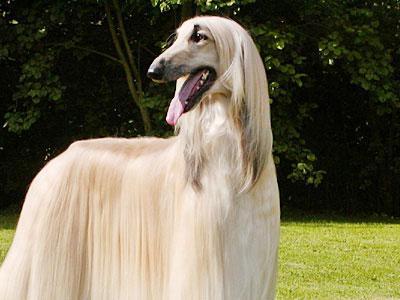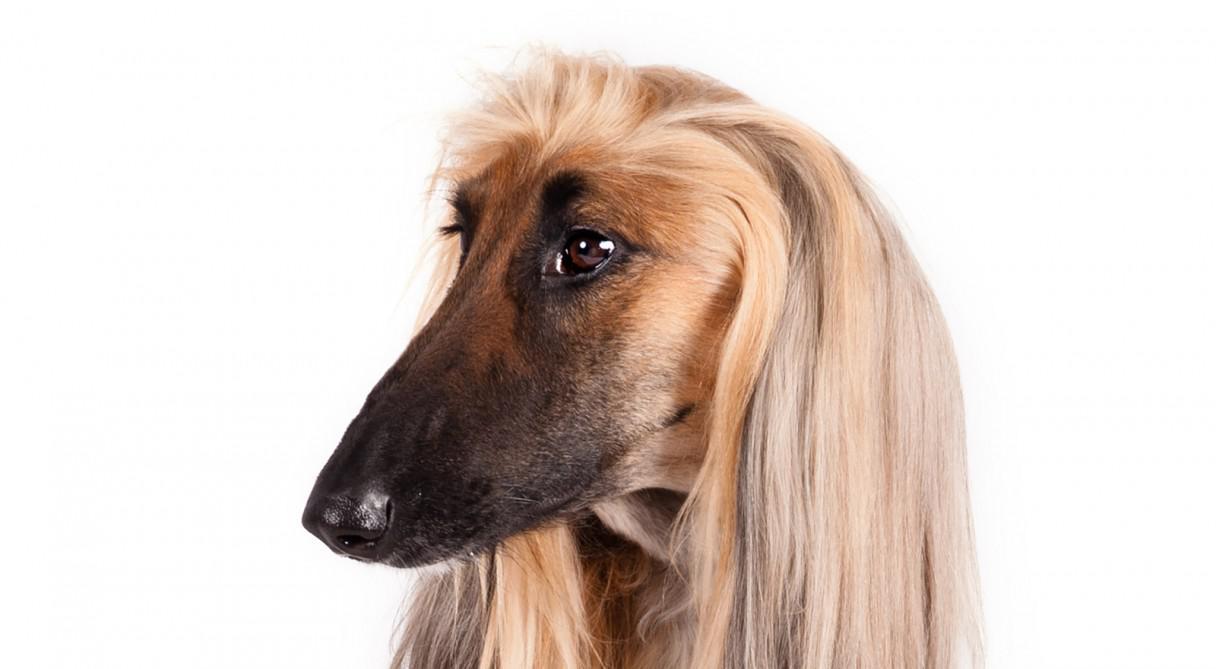The first image is the image on the left, the second image is the image on the right. Examine the images to the left and right. Is the description "An image shows a dark-haired hound lounging on furniture with throw pillows." accurate? Answer yes or no. No. The first image is the image on the left, the second image is the image on the right. For the images shown, is this caption "At least one dog in one of the images is outside on a sunny day." true? Answer yes or no. Yes. 